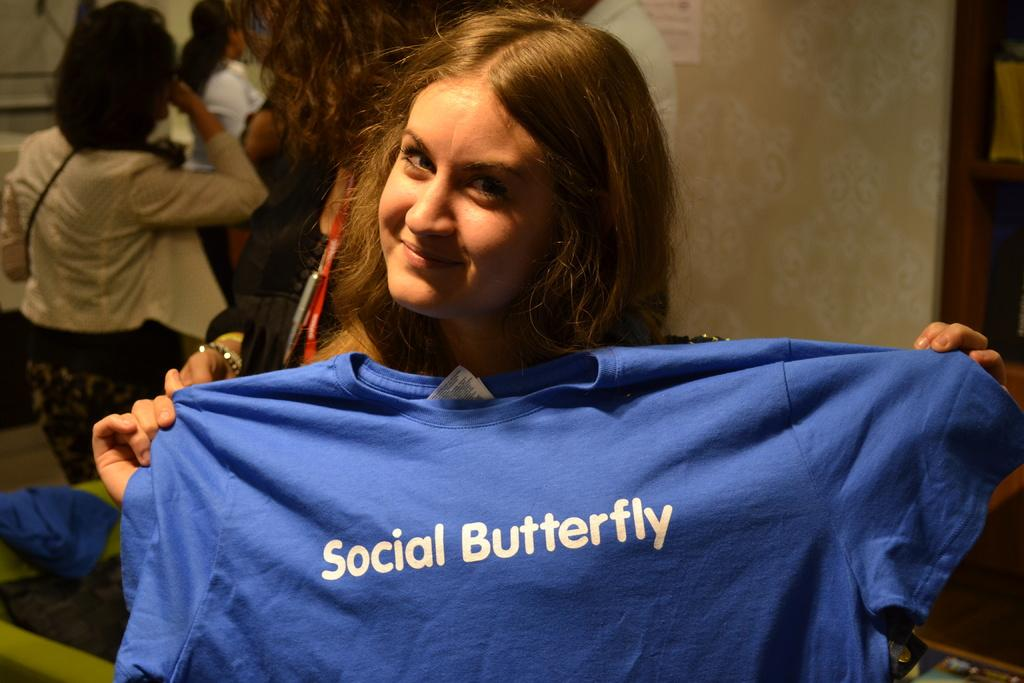What is the woman in the image holding? The woman is holding a t-shirt in the image. What can be seen on the t-shirt? There is text on the t-shirt. What is the woman doing in the image? The woman is posing for a photo. What can be seen in the background of the image? There are people and a wall visible in the background of the image. How many kittens are sitting on the coil in the image? There are no kittens or coils present in the image. 